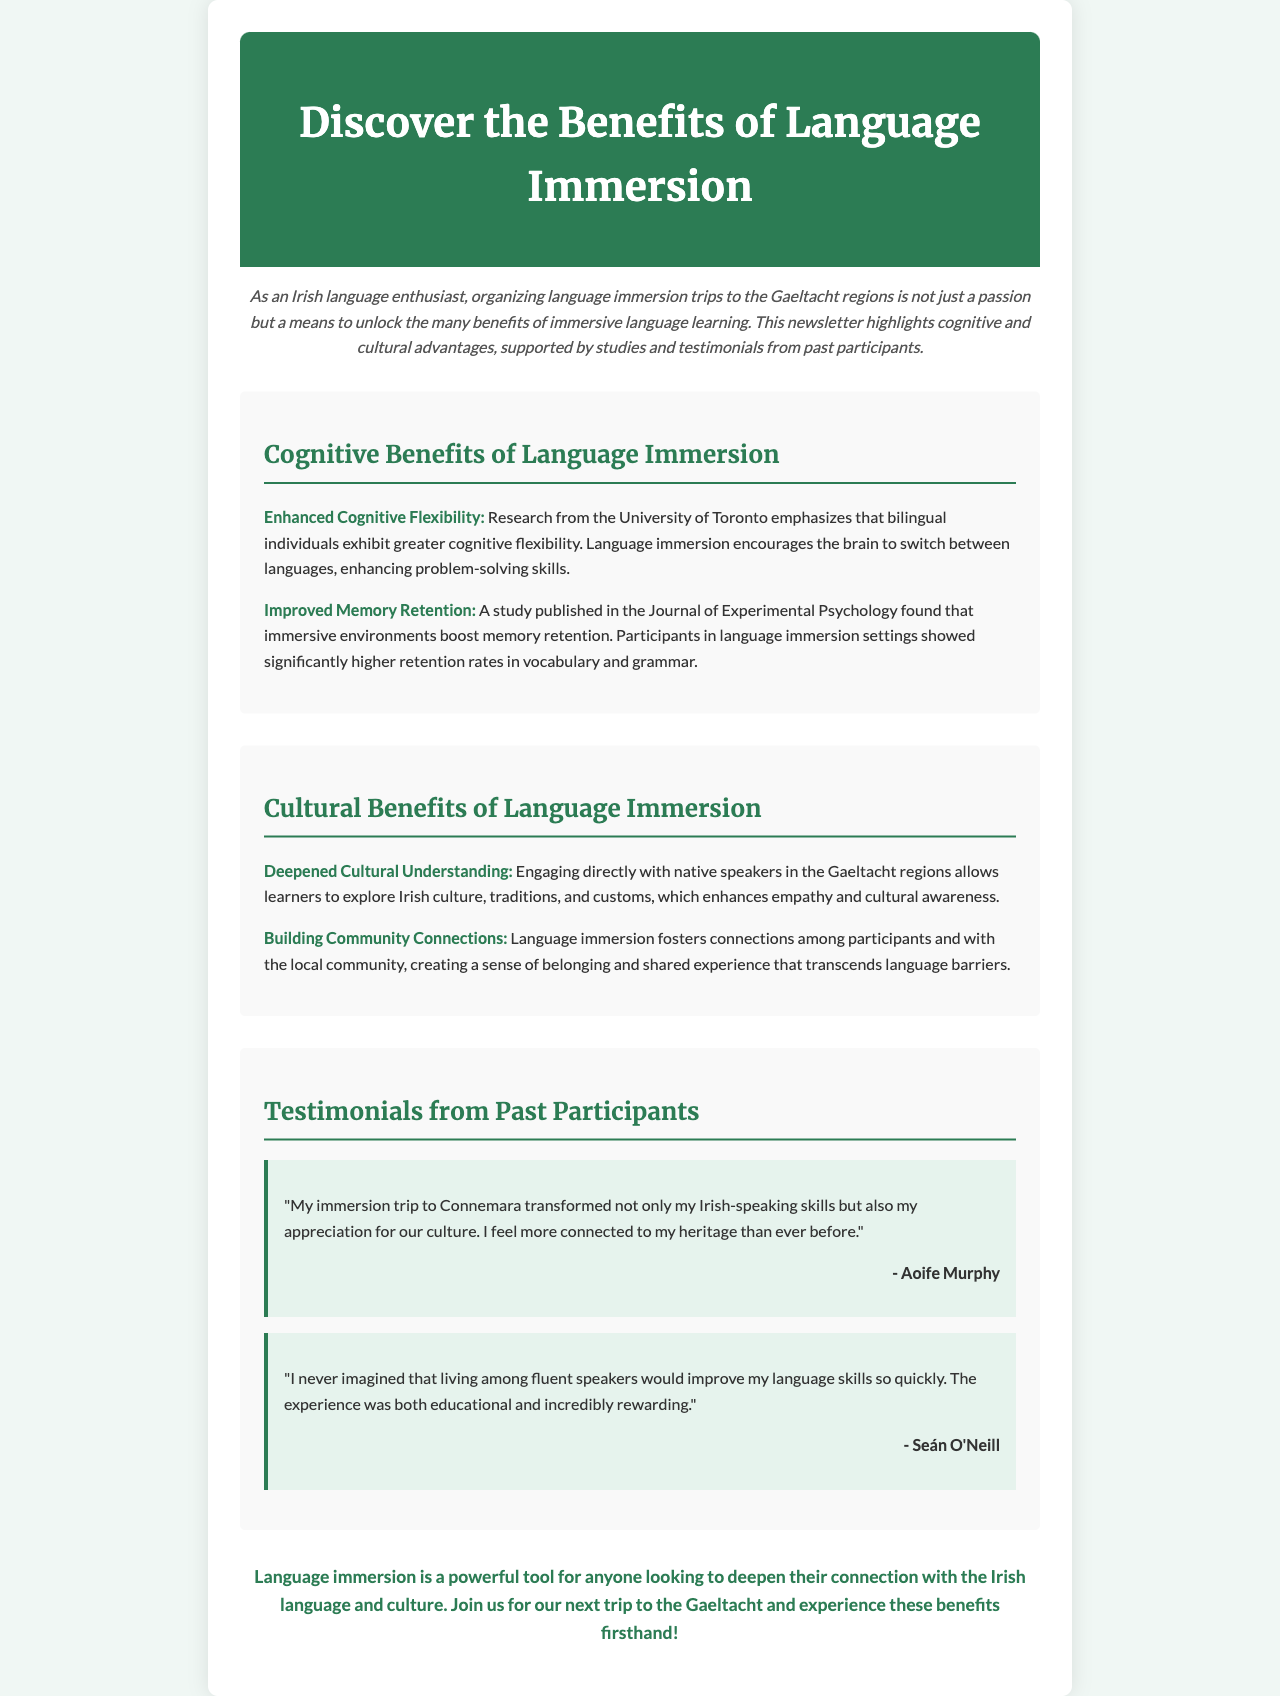What are the cognitive benefits of language immersion? The document lists "Enhanced Cognitive Flexibility" and "Improved Memory Retention" as cognitive benefits.
Answer: Enhanced Cognitive Flexibility, Improved Memory Retention Who conducted research emphasizing cognitive flexibility in bilingual individuals? The document mentions research from the University of Toronto regarding cognitive flexibility.
Answer: University of Toronto What is a cultural benefit of language immersion mentioned in the document? The document highlights "Deepened Cultural Understanding" and "Building Community Connections" as cultural benefits.
Answer: Deepened Cultural Understanding Who is a participant that shared a testimonial about their immersion trip? The document includes testimonials from participants like Aoife Murphy and Seán O'Neill.
Answer: Aoife Murphy How does language immersion affect memory retention, according to the document? A study in the document found that immersive environments boost memory retention, showing higher retention rates in vocabulary and grammar.
Answer: Boosts memory retention What does the conclusion of the newsletter encourage readers to do? The conclusion invites readers to join the next trip to the Gaeltacht to experience benefits firsthand.
Answer: Join us for our next trip to the Gaeltacht What style of feedback do the testimonials provide about language immersion? The testimonials express positive personal transformations and improvements in language skills from the immersion experience.
Answer: Positive personal transformations What color is used for the header background in the newsletter? The document specifies that the header background color is #2c7c54.
Answer: #2c7c54 